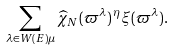<formula> <loc_0><loc_0><loc_500><loc_500>\sum _ { \lambda \in W ( E ) \mu } \widehat { \chi } _ { N } ( \varpi ^ { \lambda } ) \, ^ { \eta } \xi ( \varpi ^ { \lambda } ) .</formula> 